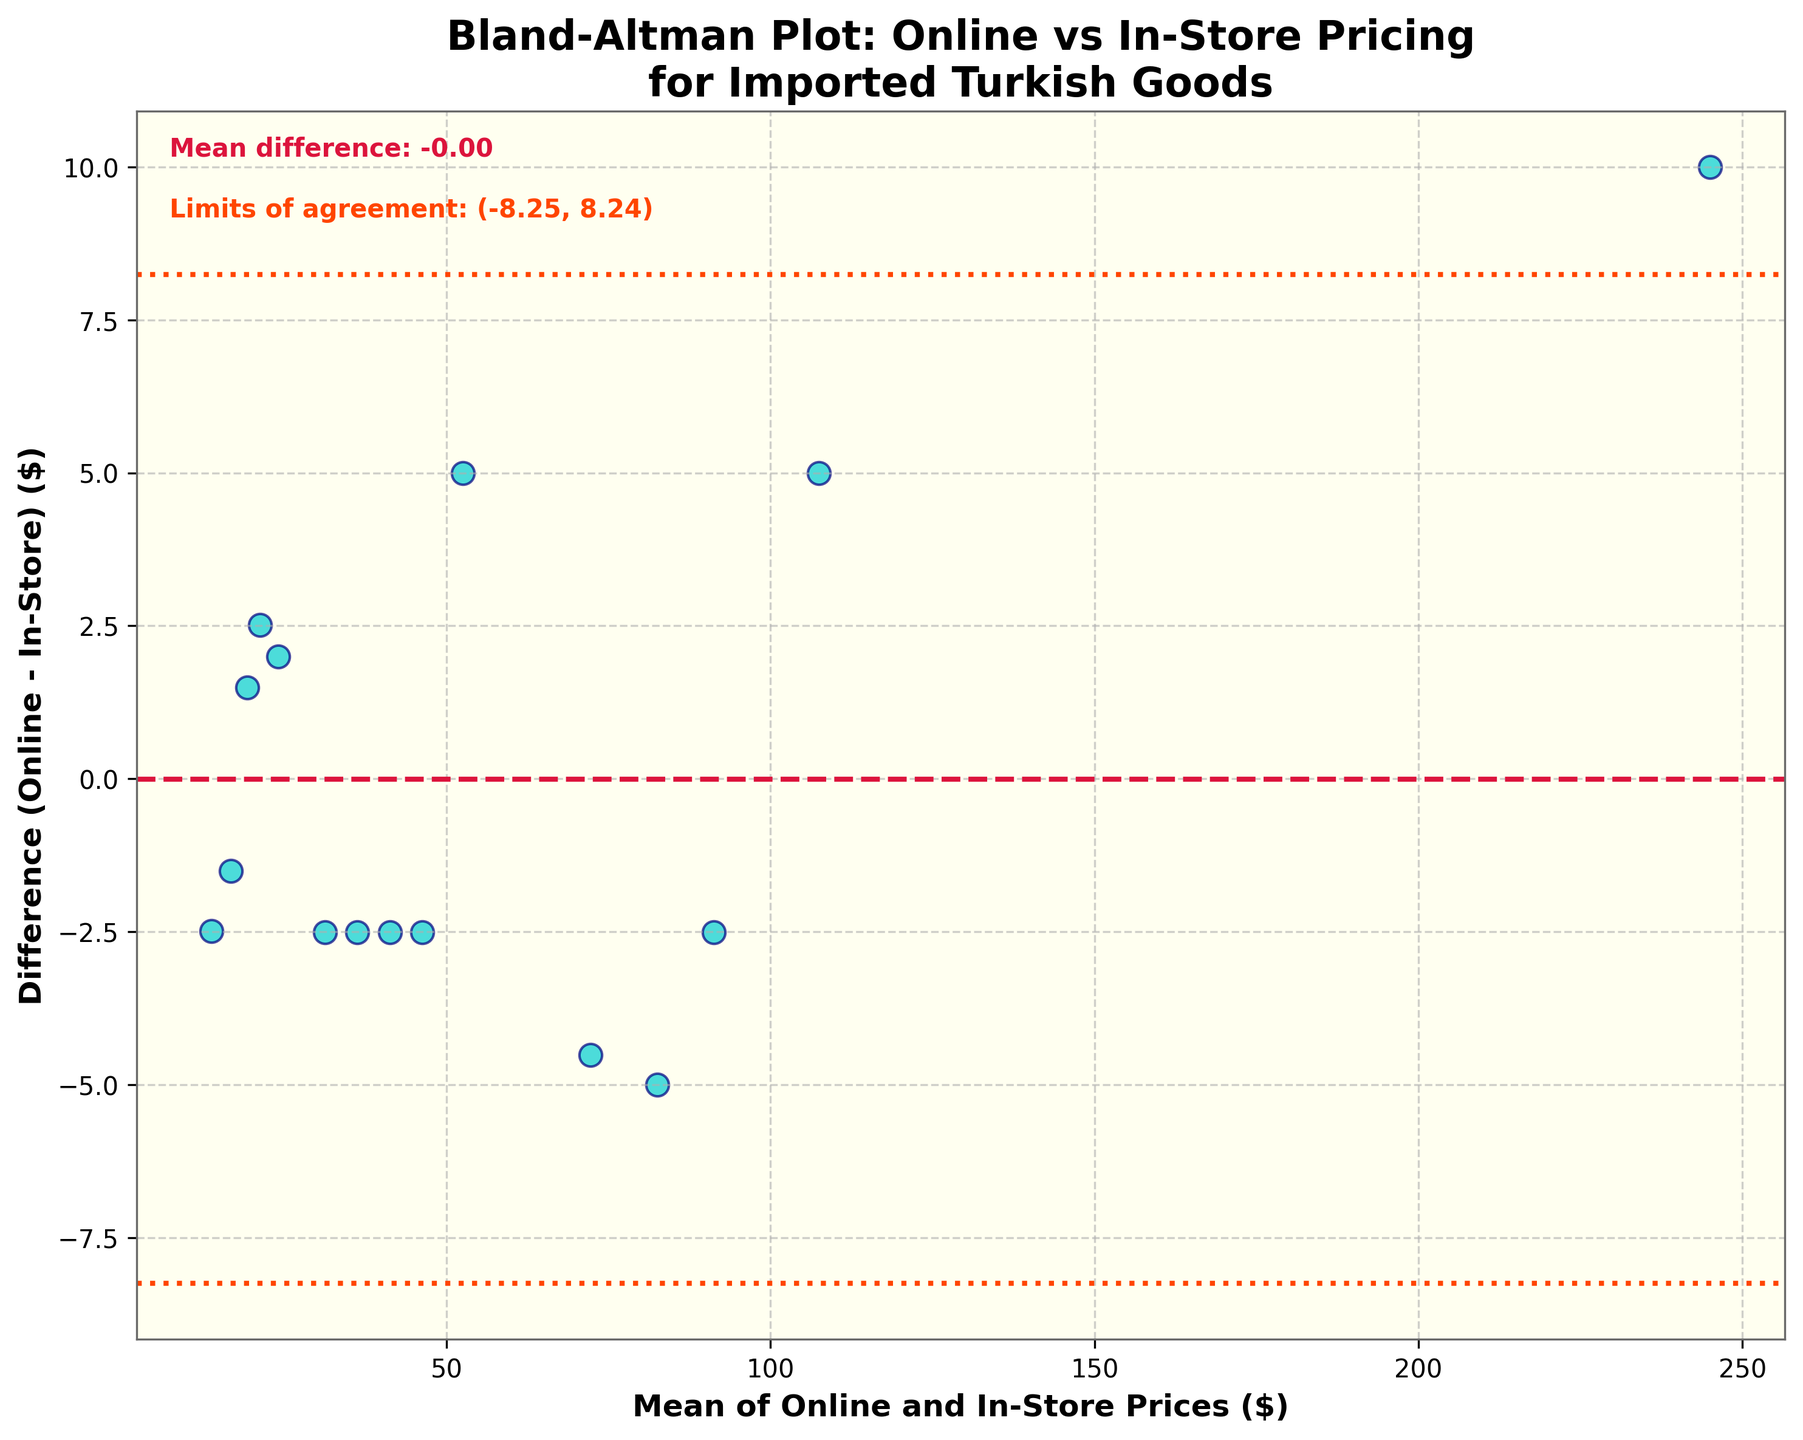What is the title of the plot? The title is usually located at the top of the plot. In this case, the title reads "Bland-Altman Plot: Online vs In-Store Pricing for Imported Turkish Goods".
Answer: Bland-Altman Plot: Online vs In-Store Pricing for Imported Turkish Goods What are the axis labels? Axis labels provide context for what is being plotted on each axis. Here, the x-axis is labeled "Mean of Online and In-Store Prices ($)" and the y-axis is labeled "Difference (Online - In-Store) ($)".
Answer: Mean of Online and In-Store Prices ($), Difference (Online - In-Store) ($) How many data points are plotted? The number of data points corresponds to the number of observations or products being compared. By counting the distinct points plotted, we see there are 15.
Answer: 15 What color are the data points? The color of the data points is consistent and easily identifiable. In this plot, the data points are dark turquoise with navy edges.
Answer: Dark turquoise What is the mean difference between online and in-store prices? The mean difference is a specific value often highlighted on a Bland-Altman plot as a dashed horizontal line. It is noted in the plot’s legend as well. Here, it is given as 2.23.
Answer: 2.23 What does the red dashed line represent? The red dashed line in the Bland-Altman plot usually signifies the mean difference between the two sets of measurements. Here, it represents the mean difference between online and in-store prices, which is 2.23.
Answer: The mean difference between online and in-store prices What do the orange dotted lines represent? The orange dotted lines represent the limits of agreement, calculated as the mean difference ± 1.96 times the standard deviation of the differences. These lines indicate the range within which most differences between the two sets of measurements fall.
Answer: Limits of agreement What are the values of the limits of agreement? The limits of agreement are provided in the figure and are calculated as the mean difference ± 1.96 times the standard deviation of the differences. In this case, they are (-1.90, 6.36).
Answer: (-1.90, 6.36) Which product has the maximum difference in prices, and what is the difference? By locating the point with the highest value on the y-axis (difference), we observe that the "Handmade Leather Slippers" have the largest difference between online and in-store prices, which is 5.00.
Answer: Handmade Leather Slippers, 5.00 Are there any negative differences, and what does a negative difference signify? A negative difference indicates that the in-store price is higher than the online price. By checking the data points positioned below the mean difference line, we confirm there are negative differences for "Handwoven Kilim Rug", "Turkish Coffee Set", and "Hammam Towel".
Answer: Yes, it signifies the in-store price is higher than the online price 